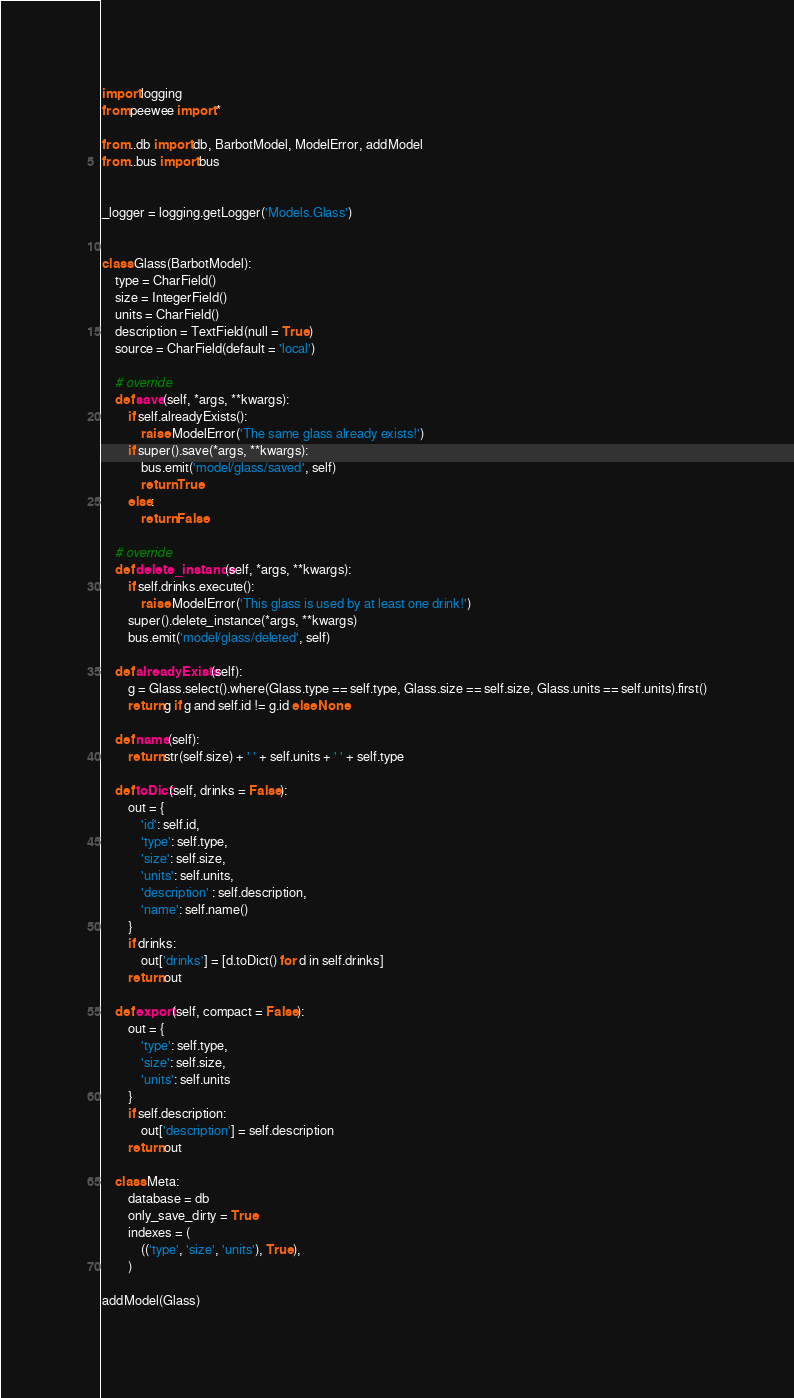<code> <loc_0><loc_0><loc_500><loc_500><_Python_>
import logging
from peewee import *

from ..db import db, BarbotModel, ModelError, addModel
from ..bus import bus


_logger = logging.getLogger('Models.Glass')


class Glass(BarbotModel):
    type = CharField()
    size = IntegerField()
    units = CharField()
    description = TextField(null = True)
    source = CharField(default = 'local')
    
    # override
    def save(self, *args, **kwargs):
        if self.alreadyExists():
            raise ModelError('The same glass already exists!')
        if super().save(*args, **kwargs):
            bus.emit('model/glass/saved', self)
            return True
        else:
            return False

    # override
    def delete_instance(self, *args, **kwargs):
        if self.drinks.execute():
            raise ModelError('This glass is used by at least one drink!')
        super().delete_instance(*args, **kwargs)
        bus.emit('model/glass/deleted', self)
            
    def alreadyExists(self):
        g = Glass.select().where(Glass.type == self.type, Glass.size == self.size, Glass.units == self.units).first()
        return g if g and self.id != g.id else None
    
    def name(self):
        return str(self.size) + ' ' + self.units + ' ' + self.type
        
    def toDict(self, drinks = False):
        out = {
            'id': self.id,
            'type': self.type,
            'size': self.size,
            'units': self.units,
            'description' : self.description,
            'name': self.name()
        }
        if drinks:
            out['drinks'] = [d.toDict() for d in self.drinks]
        return out
        
    def export(self, compact = False):
        out = {
            'type': self.type,
            'size': self.size,
            'units': self.units
        }
        if self.description:
            out['description'] = self.description
        return out

    class Meta:
        database = db
        only_save_dirty = True
        indexes = (
            (('type', 'size', 'units'), True),
        )

addModel(Glass)
</code> 